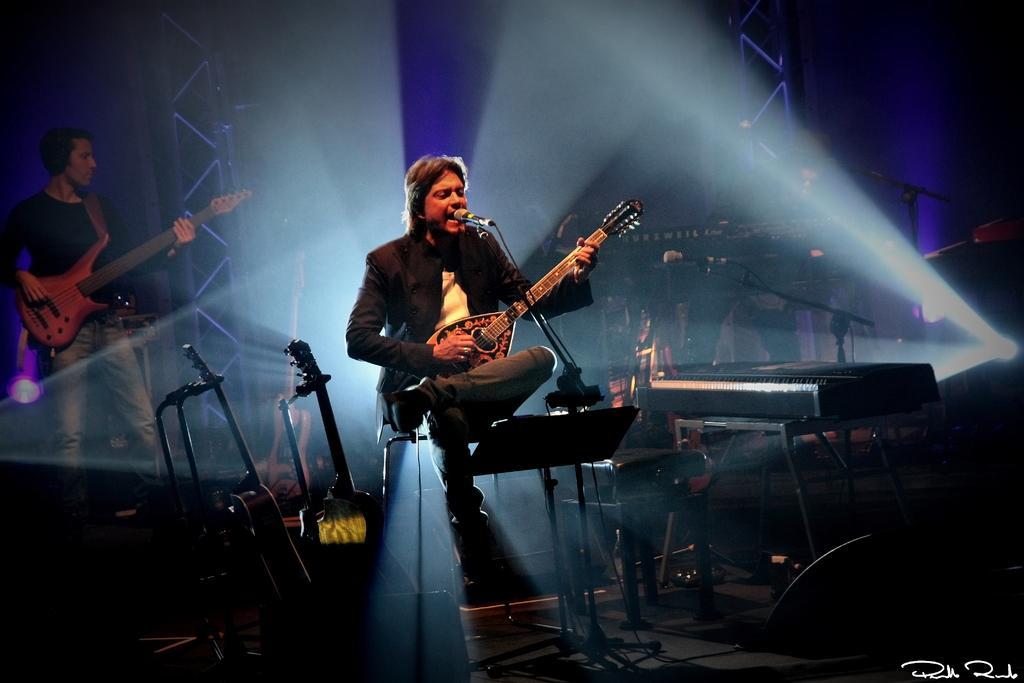In one or two sentences, can you explain what this image depicts? In this image i can see a man is sitting on a chair and playing a guitar on the microphone. On the left side a man is also playing a guitar on the stage. 